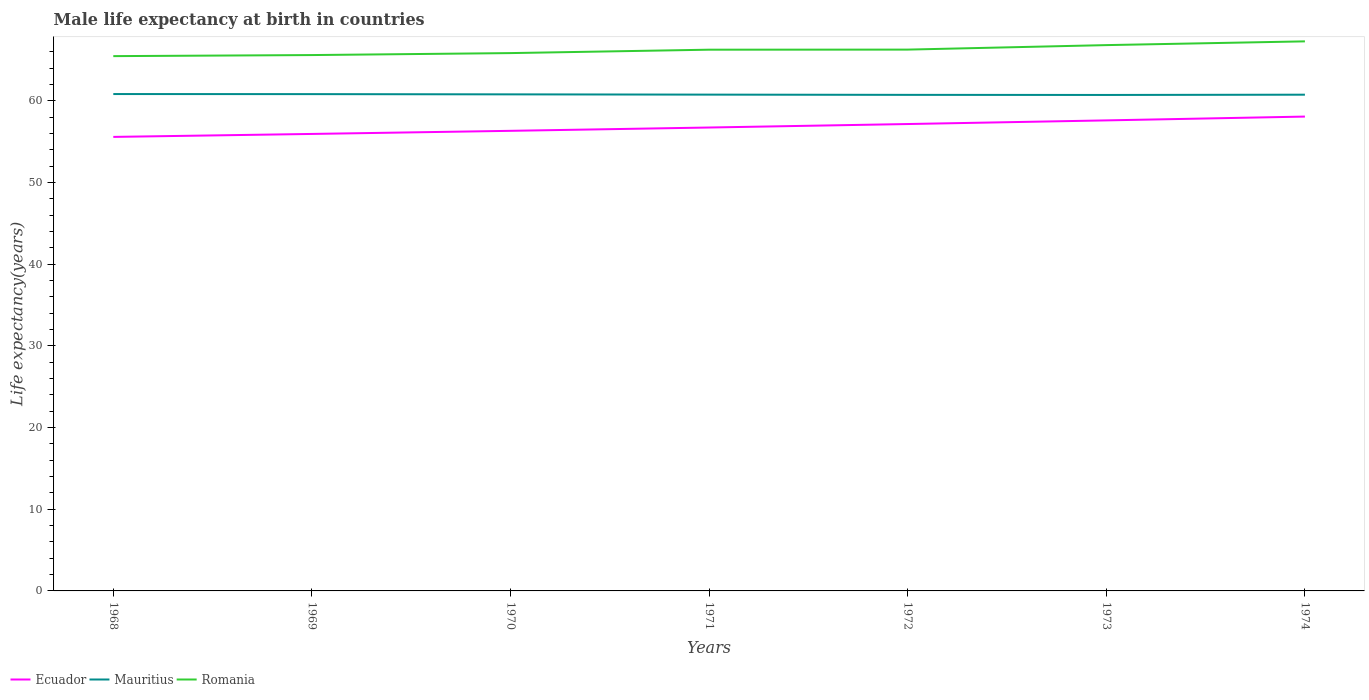Does the line corresponding to Romania intersect with the line corresponding to Mauritius?
Provide a succinct answer. No. Across all years, what is the maximum male life expectancy at birth in Ecuador?
Provide a succinct answer. 55.59. In which year was the male life expectancy at birth in Ecuador maximum?
Ensure brevity in your answer.  1968. What is the total male life expectancy at birth in Mauritius in the graph?
Offer a terse response. -0.02. What is the difference between the highest and the second highest male life expectancy at birth in Romania?
Make the answer very short. 1.81. What is the difference between the highest and the lowest male life expectancy at birth in Ecuador?
Your answer should be compact. 3. How many lines are there?
Your response must be concise. 3. How many years are there in the graph?
Make the answer very short. 7. Does the graph contain any zero values?
Offer a very short reply. No. Where does the legend appear in the graph?
Make the answer very short. Bottom left. How many legend labels are there?
Provide a succinct answer. 3. How are the legend labels stacked?
Give a very brief answer. Horizontal. What is the title of the graph?
Ensure brevity in your answer.  Male life expectancy at birth in countries. Does "Azerbaijan" appear as one of the legend labels in the graph?
Keep it short and to the point. No. What is the label or title of the X-axis?
Your answer should be compact. Years. What is the label or title of the Y-axis?
Offer a very short reply. Life expectancy(years). What is the Life expectancy(years) of Ecuador in 1968?
Offer a terse response. 55.59. What is the Life expectancy(years) of Mauritius in 1968?
Your answer should be compact. 60.84. What is the Life expectancy(years) of Romania in 1968?
Make the answer very short. 65.48. What is the Life expectancy(years) in Ecuador in 1969?
Ensure brevity in your answer.  55.95. What is the Life expectancy(years) of Mauritius in 1969?
Ensure brevity in your answer.  60.83. What is the Life expectancy(years) in Romania in 1969?
Give a very brief answer. 65.61. What is the Life expectancy(years) in Ecuador in 1970?
Make the answer very short. 56.34. What is the Life expectancy(years) of Mauritius in 1970?
Your answer should be very brief. 60.8. What is the Life expectancy(years) in Romania in 1970?
Your answer should be very brief. 65.85. What is the Life expectancy(years) of Ecuador in 1971?
Provide a short and direct response. 56.74. What is the Life expectancy(years) in Mauritius in 1971?
Give a very brief answer. 60.77. What is the Life expectancy(years) of Romania in 1971?
Provide a short and direct response. 66.27. What is the Life expectancy(years) in Ecuador in 1972?
Provide a succinct answer. 57.17. What is the Life expectancy(years) in Mauritius in 1972?
Ensure brevity in your answer.  60.74. What is the Life expectancy(years) of Romania in 1972?
Your answer should be compact. 66.28. What is the Life expectancy(years) of Ecuador in 1973?
Offer a very short reply. 57.61. What is the Life expectancy(years) in Mauritius in 1973?
Your response must be concise. 60.73. What is the Life expectancy(years) in Romania in 1973?
Provide a succinct answer. 66.83. What is the Life expectancy(years) in Ecuador in 1974?
Provide a succinct answer. 58.08. What is the Life expectancy(years) in Mauritius in 1974?
Give a very brief answer. 60.76. What is the Life expectancy(years) of Romania in 1974?
Provide a short and direct response. 67.29. Across all years, what is the maximum Life expectancy(years) in Ecuador?
Offer a terse response. 58.08. Across all years, what is the maximum Life expectancy(years) in Mauritius?
Give a very brief answer. 60.84. Across all years, what is the maximum Life expectancy(years) of Romania?
Provide a succinct answer. 67.29. Across all years, what is the minimum Life expectancy(years) of Ecuador?
Ensure brevity in your answer.  55.59. Across all years, what is the minimum Life expectancy(years) in Mauritius?
Your answer should be compact. 60.73. Across all years, what is the minimum Life expectancy(years) of Romania?
Make the answer very short. 65.48. What is the total Life expectancy(years) in Ecuador in the graph?
Your answer should be very brief. 397.48. What is the total Life expectancy(years) in Mauritius in the graph?
Ensure brevity in your answer.  425.46. What is the total Life expectancy(years) of Romania in the graph?
Offer a terse response. 463.62. What is the difference between the Life expectancy(years) in Ecuador in 1968 and that in 1969?
Your response must be concise. -0.36. What is the difference between the Life expectancy(years) in Mauritius in 1968 and that in 1969?
Your answer should be very brief. 0.01. What is the difference between the Life expectancy(years) in Romania in 1968 and that in 1969?
Ensure brevity in your answer.  -0.13. What is the difference between the Life expectancy(years) of Ecuador in 1968 and that in 1970?
Offer a very short reply. -0.74. What is the difference between the Life expectancy(years) in Mauritius in 1968 and that in 1970?
Keep it short and to the point. 0.04. What is the difference between the Life expectancy(years) of Romania in 1968 and that in 1970?
Your answer should be compact. -0.37. What is the difference between the Life expectancy(years) of Ecuador in 1968 and that in 1971?
Offer a terse response. -1.15. What is the difference between the Life expectancy(years) of Mauritius in 1968 and that in 1971?
Make the answer very short. 0.07. What is the difference between the Life expectancy(years) of Romania in 1968 and that in 1971?
Provide a succinct answer. -0.79. What is the difference between the Life expectancy(years) in Ecuador in 1968 and that in 1972?
Offer a terse response. -1.58. What is the difference between the Life expectancy(years) of Mauritius in 1968 and that in 1972?
Provide a succinct answer. 0.1. What is the difference between the Life expectancy(years) of Romania in 1968 and that in 1972?
Make the answer very short. -0.8. What is the difference between the Life expectancy(years) in Ecuador in 1968 and that in 1973?
Your answer should be compact. -2.02. What is the difference between the Life expectancy(years) of Mauritius in 1968 and that in 1973?
Offer a terse response. 0.11. What is the difference between the Life expectancy(years) in Romania in 1968 and that in 1973?
Your response must be concise. -1.35. What is the difference between the Life expectancy(years) of Ecuador in 1968 and that in 1974?
Provide a succinct answer. -2.49. What is the difference between the Life expectancy(years) in Romania in 1968 and that in 1974?
Your response must be concise. -1.81. What is the difference between the Life expectancy(years) in Ecuador in 1969 and that in 1970?
Offer a very short reply. -0.38. What is the difference between the Life expectancy(years) in Mauritius in 1969 and that in 1970?
Offer a terse response. 0.03. What is the difference between the Life expectancy(years) in Romania in 1969 and that in 1970?
Give a very brief answer. -0.24. What is the difference between the Life expectancy(years) of Ecuador in 1969 and that in 1971?
Offer a very short reply. -0.79. What is the difference between the Life expectancy(years) of Mauritius in 1969 and that in 1971?
Provide a succinct answer. 0.06. What is the difference between the Life expectancy(years) of Romania in 1969 and that in 1971?
Provide a short and direct response. -0.66. What is the difference between the Life expectancy(years) in Ecuador in 1969 and that in 1972?
Offer a very short reply. -1.21. What is the difference between the Life expectancy(years) of Mauritius in 1969 and that in 1972?
Your answer should be very brief. 0.09. What is the difference between the Life expectancy(years) of Romania in 1969 and that in 1972?
Give a very brief answer. -0.67. What is the difference between the Life expectancy(years) of Ecuador in 1969 and that in 1973?
Ensure brevity in your answer.  -1.66. What is the difference between the Life expectancy(years) in Mauritius in 1969 and that in 1973?
Offer a terse response. 0.1. What is the difference between the Life expectancy(years) of Romania in 1969 and that in 1973?
Give a very brief answer. -1.22. What is the difference between the Life expectancy(years) in Ecuador in 1969 and that in 1974?
Ensure brevity in your answer.  -2.13. What is the difference between the Life expectancy(years) in Mauritius in 1969 and that in 1974?
Your answer should be compact. 0.07. What is the difference between the Life expectancy(years) of Romania in 1969 and that in 1974?
Provide a short and direct response. -1.68. What is the difference between the Life expectancy(years) of Ecuador in 1970 and that in 1971?
Make the answer very short. -0.41. What is the difference between the Life expectancy(years) in Mauritius in 1970 and that in 1971?
Your answer should be very brief. 0.03. What is the difference between the Life expectancy(years) in Romania in 1970 and that in 1971?
Offer a very short reply. -0.42. What is the difference between the Life expectancy(years) of Ecuador in 1970 and that in 1972?
Offer a terse response. -0.83. What is the difference between the Life expectancy(years) of Mauritius in 1970 and that in 1972?
Offer a terse response. 0.06. What is the difference between the Life expectancy(years) in Romania in 1970 and that in 1972?
Offer a very short reply. -0.43. What is the difference between the Life expectancy(years) in Ecuador in 1970 and that in 1973?
Your answer should be very brief. -1.28. What is the difference between the Life expectancy(years) of Mauritius in 1970 and that in 1973?
Offer a terse response. 0.07. What is the difference between the Life expectancy(years) in Romania in 1970 and that in 1973?
Give a very brief answer. -0.98. What is the difference between the Life expectancy(years) of Ecuador in 1970 and that in 1974?
Keep it short and to the point. -1.75. What is the difference between the Life expectancy(years) in Mauritius in 1970 and that in 1974?
Your answer should be very brief. 0.04. What is the difference between the Life expectancy(years) of Romania in 1970 and that in 1974?
Provide a succinct answer. -1.44. What is the difference between the Life expectancy(years) of Ecuador in 1971 and that in 1972?
Offer a very short reply. -0.43. What is the difference between the Life expectancy(years) of Mauritius in 1971 and that in 1972?
Ensure brevity in your answer.  0.03. What is the difference between the Life expectancy(years) of Romania in 1971 and that in 1972?
Your answer should be compact. -0.01. What is the difference between the Life expectancy(years) in Ecuador in 1971 and that in 1973?
Your answer should be compact. -0.87. What is the difference between the Life expectancy(years) of Mauritius in 1971 and that in 1973?
Your response must be concise. 0.04. What is the difference between the Life expectancy(years) in Romania in 1971 and that in 1973?
Keep it short and to the point. -0.56. What is the difference between the Life expectancy(years) in Ecuador in 1971 and that in 1974?
Give a very brief answer. -1.34. What is the difference between the Life expectancy(years) in Mauritius in 1971 and that in 1974?
Keep it short and to the point. 0.01. What is the difference between the Life expectancy(years) in Romania in 1971 and that in 1974?
Give a very brief answer. -1.02. What is the difference between the Life expectancy(years) of Ecuador in 1972 and that in 1973?
Provide a succinct answer. -0.45. What is the difference between the Life expectancy(years) in Mauritius in 1972 and that in 1973?
Offer a terse response. 0.01. What is the difference between the Life expectancy(years) in Romania in 1972 and that in 1973?
Keep it short and to the point. -0.55. What is the difference between the Life expectancy(years) in Ecuador in 1972 and that in 1974?
Your answer should be very brief. -0.91. What is the difference between the Life expectancy(years) in Mauritius in 1972 and that in 1974?
Offer a terse response. -0.02. What is the difference between the Life expectancy(years) in Romania in 1972 and that in 1974?
Keep it short and to the point. -1.01. What is the difference between the Life expectancy(years) in Ecuador in 1973 and that in 1974?
Your answer should be very brief. -0.47. What is the difference between the Life expectancy(years) in Mauritius in 1973 and that in 1974?
Ensure brevity in your answer.  -0.03. What is the difference between the Life expectancy(years) of Romania in 1973 and that in 1974?
Make the answer very short. -0.46. What is the difference between the Life expectancy(years) of Ecuador in 1968 and the Life expectancy(years) of Mauritius in 1969?
Keep it short and to the point. -5.24. What is the difference between the Life expectancy(years) in Ecuador in 1968 and the Life expectancy(years) in Romania in 1969?
Your answer should be compact. -10.02. What is the difference between the Life expectancy(years) in Mauritius in 1968 and the Life expectancy(years) in Romania in 1969?
Provide a short and direct response. -4.77. What is the difference between the Life expectancy(years) in Ecuador in 1968 and the Life expectancy(years) in Mauritius in 1970?
Provide a succinct answer. -5.21. What is the difference between the Life expectancy(years) in Ecuador in 1968 and the Life expectancy(years) in Romania in 1970?
Your answer should be compact. -10.26. What is the difference between the Life expectancy(years) in Mauritius in 1968 and the Life expectancy(years) in Romania in 1970?
Your response must be concise. -5.01. What is the difference between the Life expectancy(years) of Ecuador in 1968 and the Life expectancy(years) of Mauritius in 1971?
Offer a very short reply. -5.18. What is the difference between the Life expectancy(years) in Ecuador in 1968 and the Life expectancy(years) in Romania in 1971?
Give a very brief answer. -10.68. What is the difference between the Life expectancy(years) of Mauritius in 1968 and the Life expectancy(years) of Romania in 1971?
Provide a short and direct response. -5.43. What is the difference between the Life expectancy(years) of Ecuador in 1968 and the Life expectancy(years) of Mauritius in 1972?
Make the answer very short. -5.15. What is the difference between the Life expectancy(years) in Ecuador in 1968 and the Life expectancy(years) in Romania in 1972?
Offer a very short reply. -10.69. What is the difference between the Life expectancy(years) of Mauritius in 1968 and the Life expectancy(years) of Romania in 1972?
Ensure brevity in your answer.  -5.44. What is the difference between the Life expectancy(years) of Ecuador in 1968 and the Life expectancy(years) of Mauritius in 1973?
Provide a succinct answer. -5.14. What is the difference between the Life expectancy(years) of Ecuador in 1968 and the Life expectancy(years) of Romania in 1973?
Give a very brief answer. -11.24. What is the difference between the Life expectancy(years) in Mauritius in 1968 and the Life expectancy(years) in Romania in 1973?
Offer a very short reply. -5.99. What is the difference between the Life expectancy(years) in Ecuador in 1968 and the Life expectancy(years) in Mauritius in 1974?
Your answer should be very brief. -5.17. What is the difference between the Life expectancy(years) of Ecuador in 1968 and the Life expectancy(years) of Romania in 1974?
Offer a very short reply. -11.7. What is the difference between the Life expectancy(years) in Mauritius in 1968 and the Life expectancy(years) in Romania in 1974?
Your answer should be compact. -6.45. What is the difference between the Life expectancy(years) in Ecuador in 1969 and the Life expectancy(years) in Mauritius in 1970?
Your response must be concise. -4.85. What is the difference between the Life expectancy(years) of Ecuador in 1969 and the Life expectancy(years) of Romania in 1970?
Your answer should be very brief. -9.9. What is the difference between the Life expectancy(years) in Mauritius in 1969 and the Life expectancy(years) in Romania in 1970?
Ensure brevity in your answer.  -5.03. What is the difference between the Life expectancy(years) of Ecuador in 1969 and the Life expectancy(years) of Mauritius in 1971?
Make the answer very short. -4.81. What is the difference between the Life expectancy(years) of Ecuador in 1969 and the Life expectancy(years) of Romania in 1971?
Ensure brevity in your answer.  -10.32. What is the difference between the Life expectancy(years) in Mauritius in 1969 and the Life expectancy(years) in Romania in 1971?
Your response must be concise. -5.44. What is the difference between the Life expectancy(years) of Ecuador in 1969 and the Life expectancy(years) of Mauritius in 1972?
Ensure brevity in your answer.  -4.78. What is the difference between the Life expectancy(years) in Ecuador in 1969 and the Life expectancy(years) in Romania in 1972?
Your answer should be compact. -10.33. What is the difference between the Life expectancy(years) in Mauritius in 1969 and the Life expectancy(years) in Romania in 1972?
Offer a very short reply. -5.45. What is the difference between the Life expectancy(years) of Ecuador in 1969 and the Life expectancy(years) of Mauritius in 1973?
Provide a succinct answer. -4.77. What is the difference between the Life expectancy(years) of Ecuador in 1969 and the Life expectancy(years) of Romania in 1973?
Your answer should be compact. -10.88. What is the difference between the Life expectancy(years) of Mauritius in 1969 and the Life expectancy(years) of Romania in 1973?
Your answer should be compact. -6. What is the difference between the Life expectancy(years) in Ecuador in 1969 and the Life expectancy(years) in Mauritius in 1974?
Your answer should be very brief. -4.8. What is the difference between the Life expectancy(years) in Ecuador in 1969 and the Life expectancy(years) in Romania in 1974?
Make the answer very short. -11.34. What is the difference between the Life expectancy(years) in Mauritius in 1969 and the Life expectancy(years) in Romania in 1974?
Ensure brevity in your answer.  -6.46. What is the difference between the Life expectancy(years) in Ecuador in 1970 and the Life expectancy(years) in Mauritius in 1971?
Make the answer very short. -4.43. What is the difference between the Life expectancy(years) of Ecuador in 1970 and the Life expectancy(years) of Romania in 1971?
Offer a terse response. -9.94. What is the difference between the Life expectancy(years) of Mauritius in 1970 and the Life expectancy(years) of Romania in 1971?
Ensure brevity in your answer.  -5.47. What is the difference between the Life expectancy(years) of Ecuador in 1970 and the Life expectancy(years) of Mauritius in 1972?
Make the answer very short. -4.4. What is the difference between the Life expectancy(years) in Ecuador in 1970 and the Life expectancy(years) in Romania in 1972?
Offer a terse response. -9.95. What is the difference between the Life expectancy(years) of Mauritius in 1970 and the Life expectancy(years) of Romania in 1972?
Give a very brief answer. -5.48. What is the difference between the Life expectancy(years) in Ecuador in 1970 and the Life expectancy(years) in Mauritius in 1973?
Provide a short and direct response. -4.39. What is the difference between the Life expectancy(years) of Ecuador in 1970 and the Life expectancy(years) of Romania in 1973?
Your answer should be very brief. -10.49. What is the difference between the Life expectancy(years) in Mauritius in 1970 and the Life expectancy(years) in Romania in 1973?
Offer a terse response. -6.03. What is the difference between the Life expectancy(years) of Ecuador in 1970 and the Life expectancy(years) of Mauritius in 1974?
Your response must be concise. -4.42. What is the difference between the Life expectancy(years) of Ecuador in 1970 and the Life expectancy(years) of Romania in 1974?
Ensure brevity in your answer.  -10.96. What is the difference between the Life expectancy(years) of Mauritius in 1970 and the Life expectancy(years) of Romania in 1974?
Make the answer very short. -6.49. What is the difference between the Life expectancy(years) in Ecuador in 1971 and the Life expectancy(years) in Mauritius in 1972?
Your response must be concise. -4. What is the difference between the Life expectancy(years) of Ecuador in 1971 and the Life expectancy(years) of Romania in 1972?
Give a very brief answer. -9.54. What is the difference between the Life expectancy(years) in Mauritius in 1971 and the Life expectancy(years) in Romania in 1972?
Provide a succinct answer. -5.51. What is the difference between the Life expectancy(years) in Ecuador in 1971 and the Life expectancy(years) in Mauritius in 1973?
Make the answer very short. -3.99. What is the difference between the Life expectancy(years) in Ecuador in 1971 and the Life expectancy(years) in Romania in 1973?
Provide a short and direct response. -10.09. What is the difference between the Life expectancy(years) in Mauritius in 1971 and the Life expectancy(years) in Romania in 1973?
Ensure brevity in your answer.  -6.06. What is the difference between the Life expectancy(years) in Ecuador in 1971 and the Life expectancy(years) in Mauritius in 1974?
Make the answer very short. -4.02. What is the difference between the Life expectancy(years) in Ecuador in 1971 and the Life expectancy(years) in Romania in 1974?
Give a very brief answer. -10.55. What is the difference between the Life expectancy(years) in Mauritius in 1971 and the Life expectancy(years) in Romania in 1974?
Ensure brevity in your answer.  -6.52. What is the difference between the Life expectancy(years) of Ecuador in 1972 and the Life expectancy(years) of Mauritius in 1973?
Make the answer very short. -3.56. What is the difference between the Life expectancy(years) in Ecuador in 1972 and the Life expectancy(years) in Romania in 1973?
Provide a succinct answer. -9.66. What is the difference between the Life expectancy(years) of Mauritius in 1972 and the Life expectancy(years) of Romania in 1973?
Make the answer very short. -6.09. What is the difference between the Life expectancy(years) in Ecuador in 1972 and the Life expectancy(years) in Mauritius in 1974?
Keep it short and to the point. -3.59. What is the difference between the Life expectancy(years) of Ecuador in 1972 and the Life expectancy(years) of Romania in 1974?
Provide a short and direct response. -10.12. What is the difference between the Life expectancy(years) of Mauritius in 1972 and the Life expectancy(years) of Romania in 1974?
Your response must be concise. -6.55. What is the difference between the Life expectancy(years) in Ecuador in 1973 and the Life expectancy(years) in Mauritius in 1974?
Provide a short and direct response. -3.15. What is the difference between the Life expectancy(years) of Ecuador in 1973 and the Life expectancy(years) of Romania in 1974?
Your response must be concise. -9.68. What is the difference between the Life expectancy(years) in Mauritius in 1973 and the Life expectancy(years) in Romania in 1974?
Offer a very short reply. -6.56. What is the average Life expectancy(years) in Ecuador per year?
Offer a terse response. 56.78. What is the average Life expectancy(years) in Mauritius per year?
Make the answer very short. 60.78. What is the average Life expectancy(years) in Romania per year?
Your response must be concise. 66.23. In the year 1968, what is the difference between the Life expectancy(years) of Ecuador and Life expectancy(years) of Mauritius?
Your response must be concise. -5.25. In the year 1968, what is the difference between the Life expectancy(years) of Ecuador and Life expectancy(years) of Romania?
Ensure brevity in your answer.  -9.89. In the year 1968, what is the difference between the Life expectancy(years) in Mauritius and Life expectancy(years) in Romania?
Offer a terse response. -4.64. In the year 1969, what is the difference between the Life expectancy(years) of Ecuador and Life expectancy(years) of Mauritius?
Your answer should be very brief. -4.87. In the year 1969, what is the difference between the Life expectancy(years) in Ecuador and Life expectancy(years) in Romania?
Offer a terse response. -9.66. In the year 1969, what is the difference between the Life expectancy(years) of Mauritius and Life expectancy(years) of Romania?
Give a very brief answer. -4.78. In the year 1970, what is the difference between the Life expectancy(years) of Ecuador and Life expectancy(years) of Mauritius?
Your answer should be compact. -4.46. In the year 1970, what is the difference between the Life expectancy(years) in Ecuador and Life expectancy(years) in Romania?
Keep it short and to the point. -9.52. In the year 1970, what is the difference between the Life expectancy(years) of Mauritius and Life expectancy(years) of Romania?
Keep it short and to the point. -5.05. In the year 1971, what is the difference between the Life expectancy(years) in Ecuador and Life expectancy(years) in Mauritius?
Provide a short and direct response. -4.03. In the year 1971, what is the difference between the Life expectancy(years) of Ecuador and Life expectancy(years) of Romania?
Provide a succinct answer. -9.53. In the year 1971, what is the difference between the Life expectancy(years) in Mauritius and Life expectancy(years) in Romania?
Offer a terse response. -5.5. In the year 1972, what is the difference between the Life expectancy(years) in Ecuador and Life expectancy(years) in Mauritius?
Provide a succinct answer. -3.57. In the year 1972, what is the difference between the Life expectancy(years) in Ecuador and Life expectancy(years) in Romania?
Your answer should be compact. -9.11. In the year 1972, what is the difference between the Life expectancy(years) in Mauritius and Life expectancy(years) in Romania?
Make the answer very short. -5.54. In the year 1973, what is the difference between the Life expectancy(years) of Ecuador and Life expectancy(years) of Mauritius?
Offer a terse response. -3.12. In the year 1973, what is the difference between the Life expectancy(years) in Ecuador and Life expectancy(years) in Romania?
Keep it short and to the point. -9.22. In the year 1973, what is the difference between the Life expectancy(years) of Mauritius and Life expectancy(years) of Romania?
Offer a very short reply. -6.1. In the year 1974, what is the difference between the Life expectancy(years) in Ecuador and Life expectancy(years) in Mauritius?
Your answer should be very brief. -2.68. In the year 1974, what is the difference between the Life expectancy(years) of Ecuador and Life expectancy(years) of Romania?
Offer a terse response. -9.21. In the year 1974, what is the difference between the Life expectancy(years) in Mauritius and Life expectancy(years) in Romania?
Give a very brief answer. -6.53. What is the ratio of the Life expectancy(years) of Mauritius in 1968 to that in 1969?
Your answer should be very brief. 1. What is the ratio of the Life expectancy(years) in Ecuador in 1968 to that in 1970?
Offer a terse response. 0.99. What is the ratio of the Life expectancy(years) in Mauritius in 1968 to that in 1970?
Offer a terse response. 1. What is the ratio of the Life expectancy(years) in Romania in 1968 to that in 1970?
Make the answer very short. 0.99. What is the ratio of the Life expectancy(years) of Ecuador in 1968 to that in 1971?
Your response must be concise. 0.98. What is the ratio of the Life expectancy(years) in Romania in 1968 to that in 1971?
Offer a terse response. 0.99. What is the ratio of the Life expectancy(years) in Ecuador in 1968 to that in 1972?
Ensure brevity in your answer.  0.97. What is the ratio of the Life expectancy(years) of Romania in 1968 to that in 1972?
Your response must be concise. 0.99. What is the ratio of the Life expectancy(years) in Ecuador in 1968 to that in 1973?
Your answer should be very brief. 0.96. What is the ratio of the Life expectancy(years) of Romania in 1968 to that in 1973?
Ensure brevity in your answer.  0.98. What is the ratio of the Life expectancy(years) in Ecuador in 1968 to that in 1974?
Provide a short and direct response. 0.96. What is the ratio of the Life expectancy(years) of Romania in 1968 to that in 1974?
Your answer should be compact. 0.97. What is the ratio of the Life expectancy(years) in Ecuador in 1969 to that in 1970?
Your answer should be compact. 0.99. What is the ratio of the Life expectancy(years) in Ecuador in 1969 to that in 1971?
Offer a very short reply. 0.99. What is the ratio of the Life expectancy(years) in Mauritius in 1969 to that in 1971?
Your response must be concise. 1. What is the ratio of the Life expectancy(years) in Romania in 1969 to that in 1971?
Your answer should be compact. 0.99. What is the ratio of the Life expectancy(years) of Ecuador in 1969 to that in 1972?
Provide a short and direct response. 0.98. What is the ratio of the Life expectancy(years) in Mauritius in 1969 to that in 1972?
Give a very brief answer. 1. What is the ratio of the Life expectancy(years) of Ecuador in 1969 to that in 1973?
Your answer should be compact. 0.97. What is the ratio of the Life expectancy(years) of Romania in 1969 to that in 1973?
Keep it short and to the point. 0.98. What is the ratio of the Life expectancy(years) in Ecuador in 1969 to that in 1974?
Provide a short and direct response. 0.96. What is the ratio of the Life expectancy(years) of Romania in 1969 to that in 1974?
Your answer should be compact. 0.98. What is the ratio of the Life expectancy(years) in Ecuador in 1970 to that in 1971?
Make the answer very short. 0.99. What is the ratio of the Life expectancy(years) in Mauritius in 1970 to that in 1971?
Provide a succinct answer. 1. What is the ratio of the Life expectancy(years) in Romania in 1970 to that in 1971?
Provide a succinct answer. 0.99. What is the ratio of the Life expectancy(years) of Ecuador in 1970 to that in 1972?
Ensure brevity in your answer.  0.99. What is the ratio of the Life expectancy(years) in Mauritius in 1970 to that in 1972?
Keep it short and to the point. 1. What is the ratio of the Life expectancy(years) of Ecuador in 1970 to that in 1973?
Make the answer very short. 0.98. What is the ratio of the Life expectancy(years) of Mauritius in 1970 to that in 1973?
Your answer should be very brief. 1. What is the ratio of the Life expectancy(years) of Romania in 1970 to that in 1973?
Give a very brief answer. 0.99. What is the ratio of the Life expectancy(years) of Ecuador in 1970 to that in 1974?
Provide a short and direct response. 0.97. What is the ratio of the Life expectancy(years) in Mauritius in 1970 to that in 1974?
Make the answer very short. 1. What is the ratio of the Life expectancy(years) in Romania in 1970 to that in 1974?
Give a very brief answer. 0.98. What is the ratio of the Life expectancy(years) in Mauritius in 1971 to that in 1972?
Your response must be concise. 1. What is the ratio of the Life expectancy(years) in Ecuador in 1971 to that in 1973?
Your answer should be very brief. 0.98. What is the ratio of the Life expectancy(years) of Mauritius in 1971 to that in 1973?
Your response must be concise. 1. What is the ratio of the Life expectancy(years) in Ecuador in 1971 to that in 1974?
Your answer should be compact. 0.98. What is the ratio of the Life expectancy(years) in Ecuador in 1972 to that in 1973?
Provide a succinct answer. 0.99. What is the ratio of the Life expectancy(years) of Ecuador in 1972 to that in 1974?
Make the answer very short. 0.98. What is the ratio of the Life expectancy(years) in Mauritius in 1972 to that in 1974?
Your response must be concise. 1. What is the ratio of the Life expectancy(years) in Ecuador in 1973 to that in 1974?
Provide a short and direct response. 0.99. What is the ratio of the Life expectancy(years) in Romania in 1973 to that in 1974?
Make the answer very short. 0.99. What is the difference between the highest and the second highest Life expectancy(years) of Ecuador?
Your answer should be very brief. 0.47. What is the difference between the highest and the second highest Life expectancy(years) in Mauritius?
Give a very brief answer. 0.01. What is the difference between the highest and the second highest Life expectancy(years) of Romania?
Give a very brief answer. 0.46. What is the difference between the highest and the lowest Life expectancy(years) of Ecuador?
Provide a short and direct response. 2.49. What is the difference between the highest and the lowest Life expectancy(years) of Mauritius?
Offer a terse response. 0.11. What is the difference between the highest and the lowest Life expectancy(years) of Romania?
Offer a terse response. 1.81. 